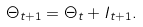Convert formula to latex. <formula><loc_0><loc_0><loc_500><loc_500>\Theta _ { t + 1 } = \Theta _ { t } + I _ { t + 1 } .</formula> 